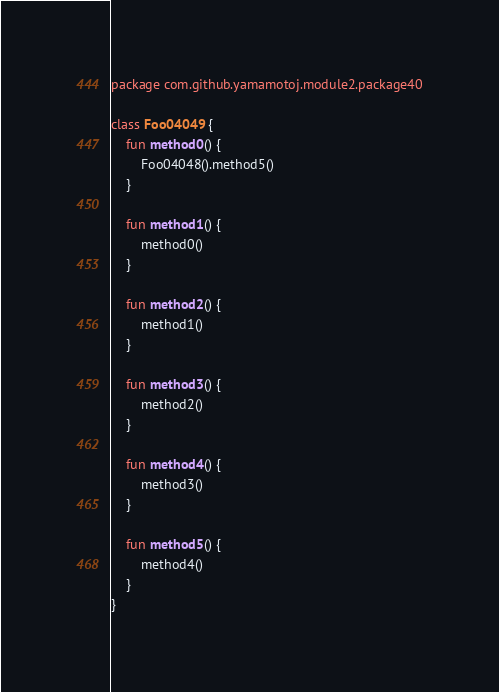<code> <loc_0><loc_0><loc_500><loc_500><_Kotlin_>package com.github.yamamotoj.module2.package40

class Foo04049 {
    fun method0() {
        Foo04048().method5()
    }

    fun method1() {
        method0()
    }

    fun method2() {
        method1()
    }

    fun method3() {
        method2()
    }

    fun method4() {
        method3()
    }

    fun method5() {
        method4()
    }
}
</code> 